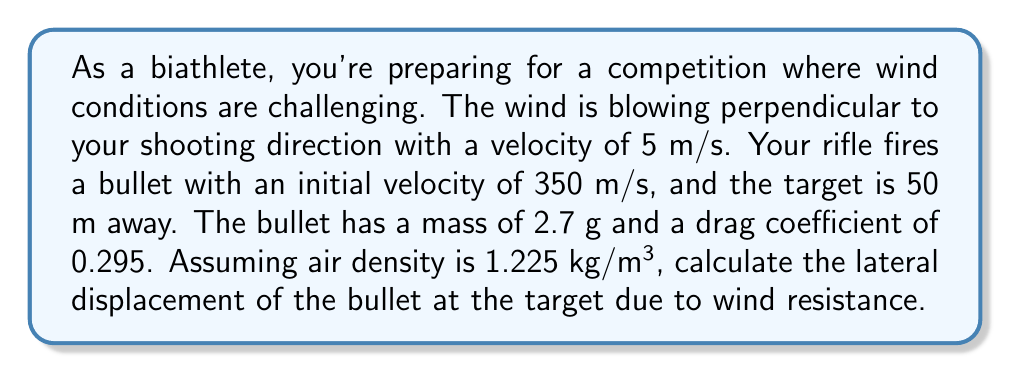What is the answer to this math problem? To solve this problem, we need to consider the effects of wind resistance on the bullet's trajectory. We'll use the drag equation and Newton's second law to model the bullet's motion.

1. First, let's calculate the cross-sectional area of the bullet. Assuming a cylindrical bullet with a diameter of 5.6 mm:

   $A = \pi r^2 = \pi (0.0028 \text{ m})^2 = 2.463 \times 10^{-5} \text{ m}^2$

2. The drag force due to wind is given by:

   $$F_d = \frac{1}{2} \rho v^2 C_d A$$

   where $\rho$ is air density, $v$ is wind velocity, $C_d$ is drag coefficient, and $A$ is cross-sectional area.

3. Substituting the values:

   $$F_d = \frac{1}{2} (1.225 \text{ kg/m}^3) (5 \text{ m/s})^2 (0.295) (2.463 \times 10^{-5} \text{ m}^2) = 5.563 \times 10^{-4} \text{ N}$$

4. Using Newton's second law, we can find the acceleration of the bullet due to wind:

   $$a = \frac{F_d}{m} = \frac{5.563 \times 10^{-4} \text{ N}}{0.0027 \text{ kg}} = 0.206 \text{ m/s}^2$$

5. The time of flight can be calculated using the initial velocity and distance to the target:

   $$t = \frac{d}{v_0} = \frac{50 \text{ m}}{350 \text{ m/s}} = 0.143 \text{ s}$$

6. The lateral displacement due to wind can be calculated using the equation of motion:

   $$x = \frac{1}{2} a t^2$$

   $$x = \frac{1}{2} (0.206 \text{ m/s}^2) (0.143 \text{ s})^2 = 0.00210 \text{ m}$$

Therefore, the lateral displacement of the bullet at the target due to wind resistance is approximately 2.10 mm.
Answer: The lateral displacement of the bullet at the target due to wind resistance is 2.10 mm. 